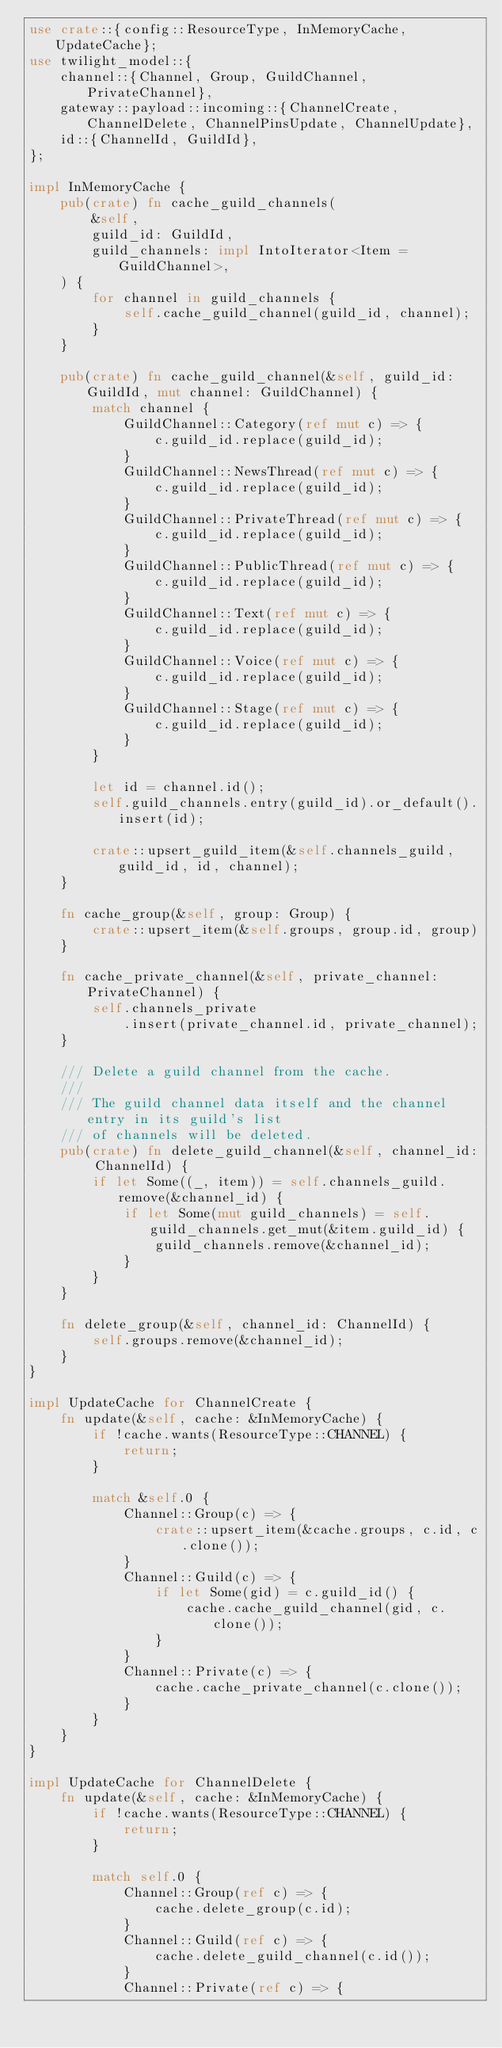<code> <loc_0><loc_0><loc_500><loc_500><_Rust_>use crate::{config::ResourceType, InMemoryCache, UpdateCache};
use twilight_model::{
    channel::{Channel, Group, GuildChannel, PrivateChannel},
    gateway::payload::incoming::{ChannelCreate, ChannelDelete, ChannelPinsUpdate, ChannelUpdate},
    id::{ChannelId, GuildId},
};

impl InMemoryCache {
    pub(crate) fn cache_guild_channels(
        &self,
        guild_id: GuildId,
        guild_channels: impl IntoIterator<Item = GuildChannel>,
    ) {
        for channel in guild_channels {
            self.cache_guild_channel(guild_id, channel);
        }
    }

    pub(crate) fn cache_guild_channel(&self, guild_id: GuildId, mut channel: GuildChannel) {
        match channel {
            GuildChannel::Category(ref mut c) => {
                c.guild_id.replace(guild_id);
            }
            GuildChannel::NewsThread(ref mut c) => {
                c.guild_id.replace(guild_id);
            }
            GuildChannel::PrivateThread(ref mut c) => {
                c.guild_id.replace(guild_id);
            }
            GuildChannel::PublicThread(ref mut c) => {
                c.guild_id.replace(guild_id);
            }
            GuildChannel::Text(ref mut c) => {
                c.guild_id.replace(guild_id);
            }
            GuildChannel::Voice(ref mut c) => {
                c.guild_id.replace(guild_id);
            }
            GuildChannel::Stage(ref mut c) => {
                c.guild_id.replace(guild_id);
            }
        }

        let id = channel.id();
        self.guild_channels.entry(guild_id).or_default().insert(id);

        crate::upsert_guild_item(&self.channels_guild, guild_id, id, channel);
    }

    fn cache_group(&self, group: Group) {
        crate::upsert_item(&self.groups, group.id, group)
    }

    fn cache_private_channel(&self, private_channel: PrivateChannel) {
        self.channels_private
            .insert(private_channel.id, private_channel);
    }

    /// Delete a guild channel from the cache.
    ///
    /// The guild channel data itself and the channel entry in its guild's list
    /// of channels will be deleted.
    pub(crate) fn delete_guild_channel(&self, channel_id: ChannelId) {
        if let Some((_, item)) = self.channels_guild.remove(&channel_id) {
            if let Some(mut guild_channels) = self.guild_channels.get_mut(&item.guild_id) {
                guild_channels.remove(&channel_id);
            }
        }
    }

    fn delete_group(&self, channel_id: ChannelId) {
        self.groups.remove(&channel_id);
    }
}

impl UpdateCache for ChannelCreate {
    fn update(&self, cache: &InMemoryCache) {
        if !cache.wants(ResourceType::CHANNEL) {
            return;
        }

        match &self.0 {
            Channel::Group(c) => {
                crate::upsert_item(&cache.groups, c.id, c.clone());
            }
            Channel::Guild(c) => {
                if let Some(gid) = c.guild_id() {
                    cache.cache_guild_channel(gid, c.clone());
                }
            }
            Channel::Private(c) => {
                cache.cache_private_channel(c.clone());
            }
        }
    }
}

impl UpdateCache for ChannelDelete {
    fn update(&self, cache: &InMemoryCache) {
        if !cache.wants(ResourceType::CHANNEL) {
            return;
        }

        match self.0 {
            Channel::Group(ref c) => {
                cache.delete_group(c.id);
            }
            Channel::Guild(ref c) => {
                cache.delete_guild_channel(c.id());
            }
            Channel::Private(ref c) => {</code> 